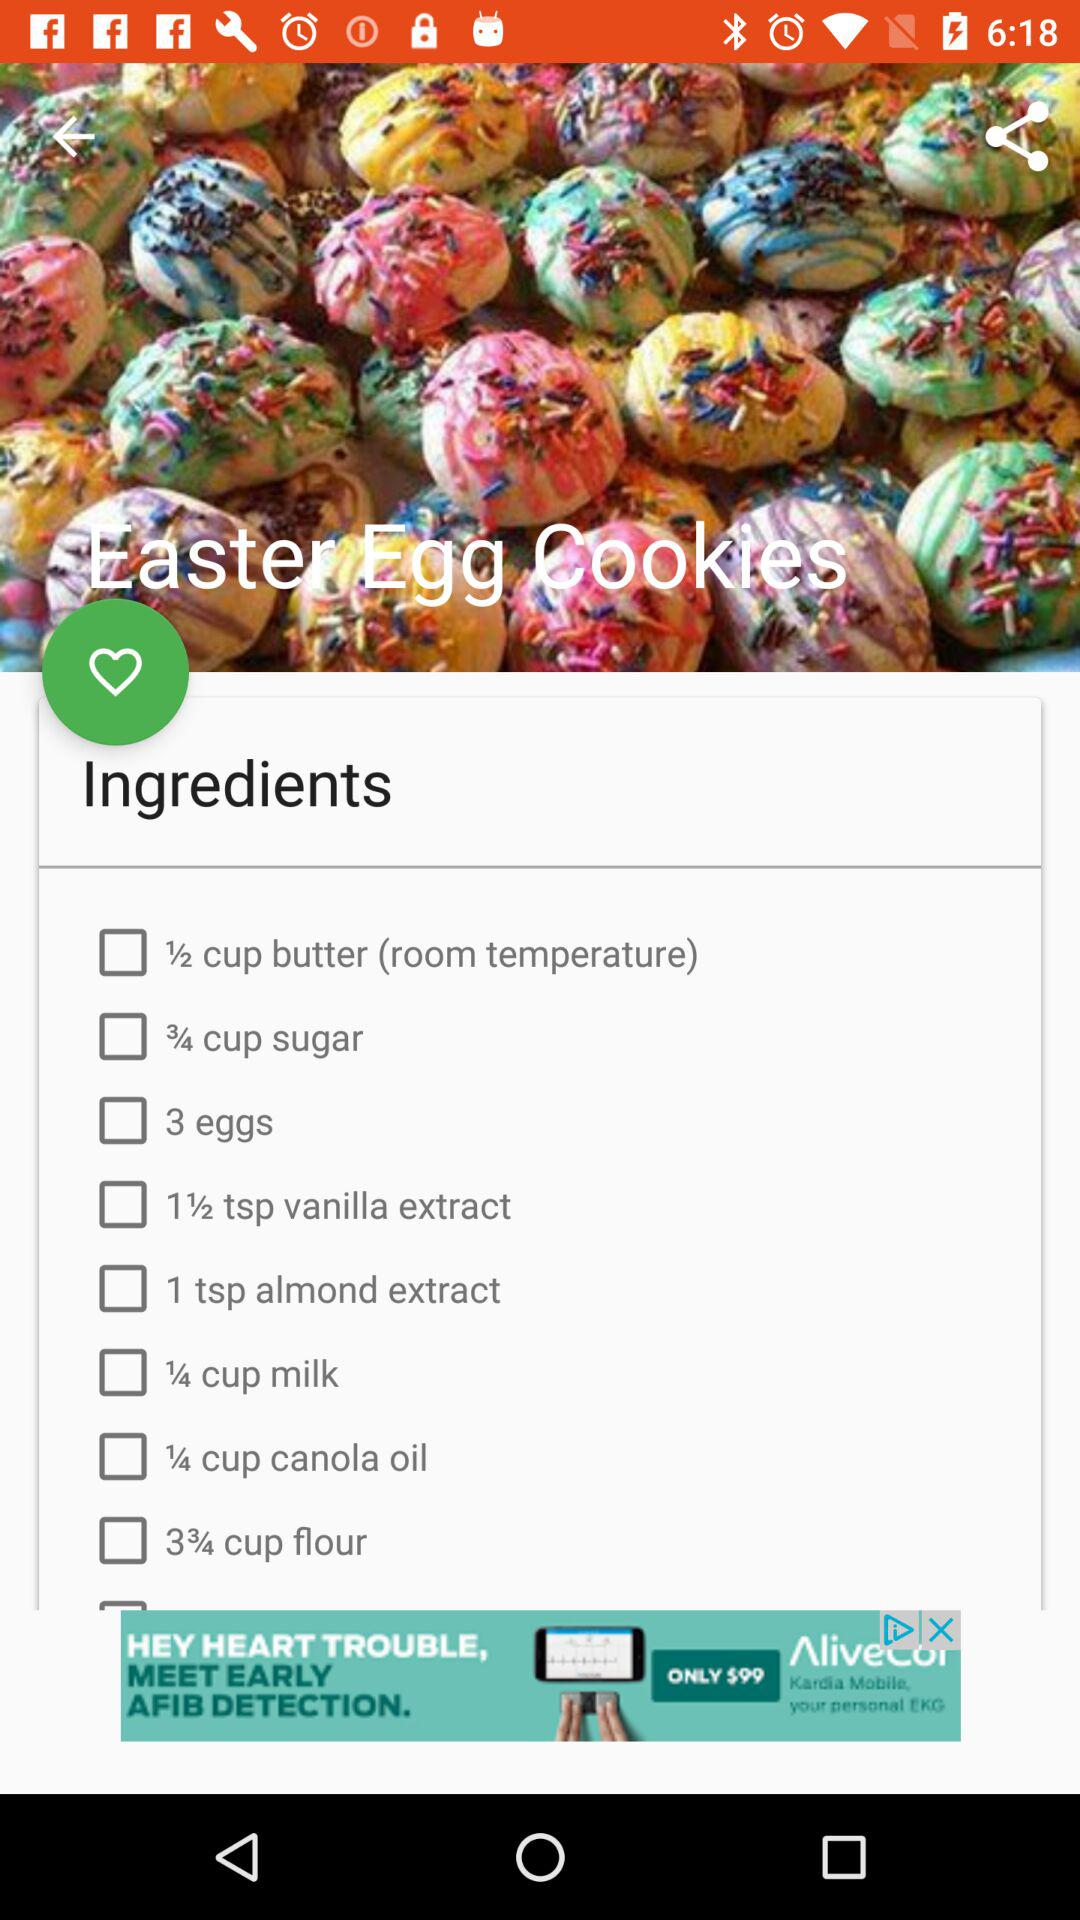What is the required amount of sugar for the dish? The required amount of sugar is ¾ cup. 